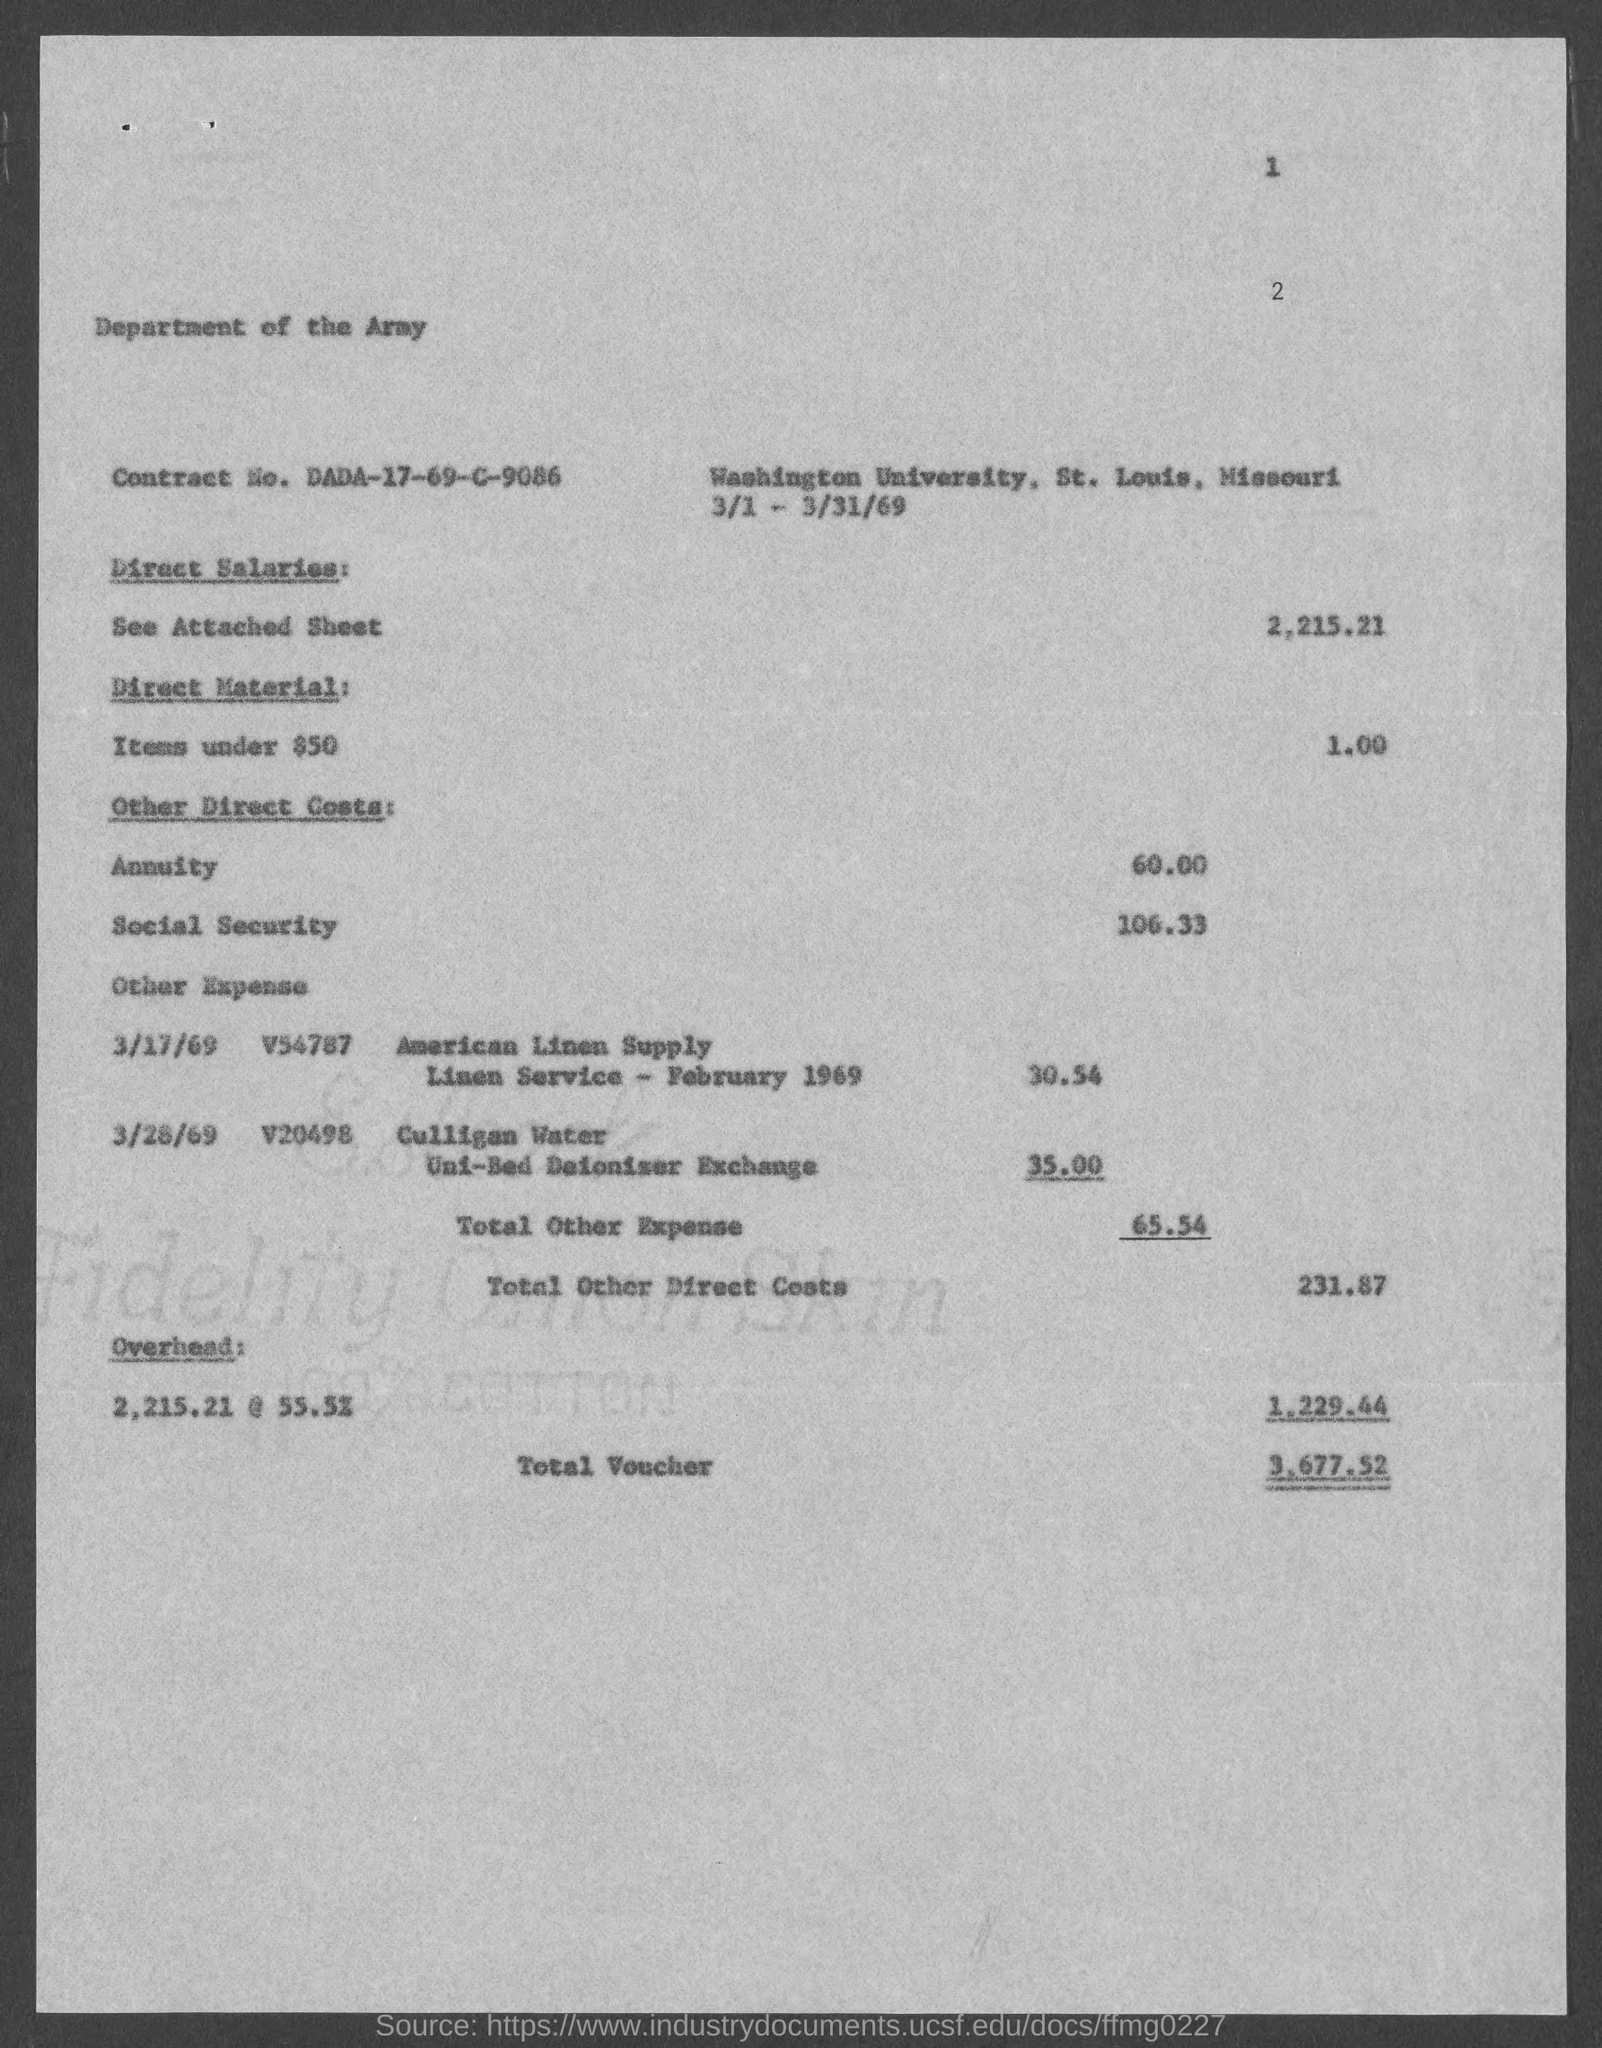What is the Contract No.?
Keep it short and to the point. DADA-17-69-C-9086. What is the total voucher?
Ensure brevity in your answer.  3,677.52. 